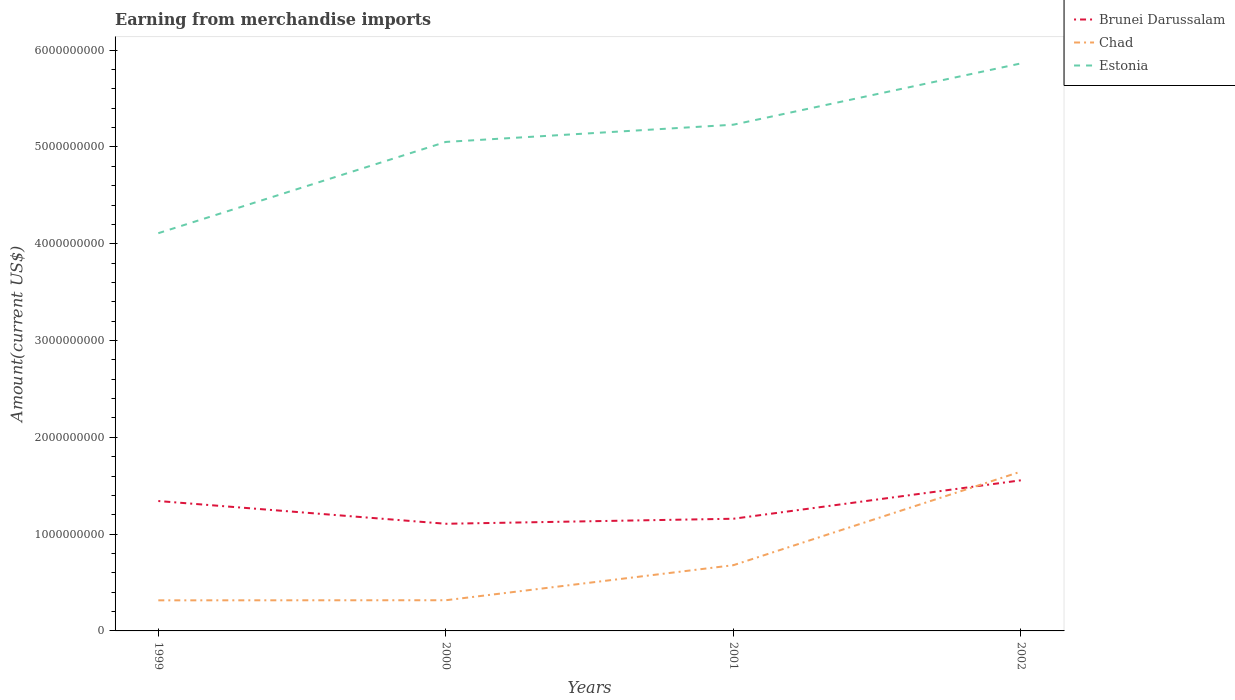How many different coloured lines are there?
Your response must be concise. 3. Is the number of lines equal to the number of legend labels?
Give a very brief answer. Yes. Across all years, what is the maximum amount earned from merchandise imports in Estonia?
Give a very brief answer. 4.11e+09. In which year was the amount earned from merchandise imports in Brunei Darussalam maximum?
Make the answer very short. 2000. What is the total amount earned from merchandise imports in Brunei Darussalam in the graph?
Give a very brief answer. -2.14e+08. What is the difference between the highest and the second highest amount earned from merchandise imports in Chad?
Provide a short and direct response. 1.33e+09. What is the difference between the highest and the lowest amount earned from merchandise imports in Chad?
Provide a succinct answer. 1. How many lines are there?
Offer a very short reply. 3. How many years are there in the graph?
Your answer should be compact. 4. Where does the legend appear in the graph?
Provide a succinct answer. Top right. How are the legend labels stacked?
Ensure brevity in your answer.  Vertical. What is the title of the graph?
Your answer should be compact. Earning from merchandise imports. Does "Andorra" appear as one of the legend labels in the graph?
Keep it short and to the point. No. What is the label or title of the X-axis?
Provide a succinct answer. Years. What is the label or title of the Y-axis?
Ensure brevity in your answer.  Amount(current US$). What is the Amount(current US$) in Brunei Darussalam in 1999?
Your response must be concise. 1.34e+09. What is the Amount(current US$) in Chad in 1999?
Offer a very short reply. 3.16e+08. What is the Amount(current US$) in Estonia in 1999?
Make the answer very short. 4.11e+09. What is the Amount(current US$) in Brunei Darussalam in 2000?
Provide a succinct answer. 1.11e+09. What is the Amount(current US$) of Chad in 2000?
Your response must be concise. 3.17e+08. What is the Amount(current US$) of Estonia in 2000?
Offer a very short reply. 5.05e+09. What is the Amount(current US$) of Brunei Darussalam in 2001?
Your answer should be compact. 1.16e+09. What is the Amount(current US$) of Chad in 2001?
Offer a terse response. 6.79e+08. What is the Amount(current US$) of Estonia in 2001?
Provide a succinct answer. 5.23e+09. What is the Amount(current US$) of Brunei Darussalam in 2002?
Your answer should be very brief. 1.56e+09. What is the Amount(current US$) of Chad in 2002?
Your answer should be very brief. 1.65e+09. What is the Amount(current US$) in Estonia in 2002?
Provide a short and direct response. 5.86e+09. Across all years, what is the maximum Amount(current US$) of Brunei Darussalam?
Keep it short and to the point. 1.56e+09. Across all years, what is the maximum Amount(current US$) in Chad?
Ensure brevity in your answer.  1.65e+09. Across all years, what is the maximum Amount(current US$) of Estonia?
Offer a terse response. 5.86e+09. Across all years, what is the minimum Amount(current US$) of Brunei Darussalam?
Make the answer very short. 1.11e+09. Across all years, what is the minimum Amount(current US$) of Chad?
Provide a short and direct response. 3.16e+08. Across all years, what is the minimum Amount(current US$) in Estonia?
Provide a short and direct response. 4.11e+09. What is the total Amount(current US$) of Brunei Darussalam in the graph?
Your answer should be compact. 5.16e+09. What is the total Amount(current US$) of Chad in the graph?
Your response must be concise. 2.96e+09. What is the total Amount(current US$) of Estonia in the graph?
Your answer should be very brief. 2.03e+1. What is the difference between the Amount(current US$) of Brunei Darussalam in 1999 and that in 2000?
Your response must be concise. 2.35e+08. What is the difference between the Amount(current US$) in Chad in 1999 and that in 2000?
Provide a succinct answer. -1.00e+06. What is the difference between the Amount(current US$) in Estonia in 1999 and that in 2000?
Your response must be concise. -9.43e+08. What is the difference between the Amount(current US$) of Brunei Darussalam in 1999 and that in 2001?
Keep it short and to the point. 1.83e+08. What is the difference between the Amount(current US$) of Chad in 1999 and that in 2001?
Make the answer very short. -3.63e+08. What is the difference between the Amount(current US$) in Estonia in 1999 and that in 2001?
Provide a short and direct response. -1.12e+09. What is the difference between the Amount(current US$) in Brunei Darussalam in 1999 and that in 2002?
Keep it short and to the point. -2.14e+08. What is the difference between the Amount(current US$) in Chad in 1999 and that in 2002?
Provide a short and direct response. -1.33e+09. What is the difference between the Amount(current US$) of Estonia in 1999 and that in 2002?
Give a very brief answer. -1.75e+09. What is the difference between the Amount(current US$) of Brunei Darussalam in 2000 and that in 2001?
Offer a terse response. -5.20e+07. What is the difference between the Amount(current US$) in Chad in 2000 and that in 2001?
Provide a succinct answer. -3.62e+08. What is the difference between the Amount(current US$) of Estonia in 2000 and that in 2001?
Provide a short and direct response. -1.78e+08. What is the difference between the Amount(current US$) in Brunei Darussalam in 2000 and that in 2002?
Offer a very short reply. -4.49e+08. What is the difference between the Amount(current US$) of Chad in 2000 and that in 2002?
Your response must be concise. -1.33e+09. What is the difference between the Amount(current US$) in Estonia in 2000 and that in 2002?
Give a very brief answer. -8.11e+08. What is the difference between the Amount(current US$) of Brunei Darussalam in 2001 and that in 2002?
Make the answer very short. -3.97e+08. What is the difference between the Amount(current US$) in Chad in 2001 and that in 2002?
Provide a succinct answer. -9.67e+08. What is the difference between the Amount(current US$) in Estonia in 2001 and that in 2002?
Ensure brevity in your answer.  -6.33e+08. What is the difference between the Amount(current US$) in Brunei Darussalam in 1999 and the Amount(current US$) in Chad in 2000?
Ensure brevity in your answer.  1.02e+09. What is the difference between the Amount(current US$) of Brunei Darussalam in 1999 and the Amount(current US$) of Estonia in 2000?
Offer a terse response. -3.71e+09. What is the difference between the Amount(current US$) in Chad in 1999 and the Amount(current US$) in Estonia in 2000?
Provide a short and direct response. -4.74e+09. What is the difference between the Amount(current US$) in Brunei Darussalam in 1999 and the Amount(current US$) in Chad in 2001?
Provide a succinct answer. 6.63e+08. What is the difference between the Amount(current US$) in Brunei Darussalam in 1999 and the Amount(current US$) in Estonia in 2001?
Offer a very short reply. -3.89e+09. What is the difference between the Amount(current US$) of Chad in 1999 and the Amount(current US$) of Estonia in 2001?
Give a very brief answer. -4.91e+09. What is the difference between the Amount(current US$) in Brunei Darussalam in 1999 and the Amount(current US$) in Chad in 2002?
Provide a succinct answer. -3.04e+08. What is the difference between the Amount(current US$) in Brunei Darussalam in 1999 and the Amount(current US$) in Estonia in 2002?
Offer a terse response. -4.52e+09. What is the difference between the Amount(current US$) in Chad in 1999 and the Amount(current US$) in Estonia in 2002?
Offer a terse response. -5.55e+09. What is the difference between the Amount(current US$) of Brunei Darussalam in 2000 and the Amount(current US$) of Chad in 2001?
Offer a very short reply. 4.28e+08. What is the difference between the Amount(current US$) of Brunei Darussalam in 2000 and the Amount(current US$) of Estonia in 2001?
Provide a short and direct response. -4.12e+09. What is the difference between the Amount(current US$) of Chad in 2000 and the Amount(current US$) of Estonia in 2001?
Provide a short and direct response. -4.91e+09. What is the difference between the Amount(current US$) of Brunei Darussalam in 2000 and the Amount(current US$) of Chad in 2002?
Ensure brevity in your answer.  -5.39e+08. What is the difference between the Amount(current US$) in Brunei Darussalam in 2000 and the Amount(current US$) in Estonia in 2002?
Keep it short and to the point. -4.76e+09. What is the difference between the Amount(current US$) in Chad in 2000 and the Amount(current US$) in Estonia in 2002?
Your response must be concise. -5.55e+09. What is the difference between the Amount(current US$) of Brunei Darussalam in 2001 and the Amount(current US$) of Chad in 2002?
Give a very brief answer. -4.87e+08. What is the difference between the Amount(current US$) of Brunei Darussalam in 2001 and the Amount(current US$) of Estonia in 2002?
Ensure brevity in your answer.  -4.70e+09. What is the difference between the Amount(current US$) of Chad in 2001 and the Amount(current US$) of Estonia in 2002?
Provide a short and direct response. -5.18e+09. What is the average Amount(current US$) in Brunei Darussalam per year?
Give a very brief answer. 1.29e+09. What is the average Amount(current US$) in Chad per year?
Make the answer very short. 7.40e+08. What is the average Amount(current US$) in Estonia per year?
Provide a succinct answer. 5.06e+09. In the year 1999, what is the difference between the Amount(current US$) of Brunei Darussalam and Amount(current US$) of Chad?
Offer a terse response. 1.03e+09. In the year 1999, what is the difference between the Amount(current US$) in Brunei Darussalam and Amount(current US$) in Estonia?
Offer a very short reply. -2.77e+09. In the year 1999, what is the difference between the Amount(current US$) in Chad and Amount(current US$) in Estonia?
Provide a succinct answer. -3.79e+09. In the year 2000, what is the difference between the Amount(current US$) in Brunei Darussalam and Amount(current US$) in Chad?
Your response must be concise. 7.90e+08. In the year 2000, what is the difference between the Amount(current US$) of Brunei Darussalam and Amount(current US$) of Estonia?
Keep it short and to the point. -3.94e+09. In the year 2000, what is the difference between the Amount(current US$) in Chad and Amount(current US$) in Estonia?
Provide a short and direct response. -4.74e+09. In the year 2001, what is the difference between the Amount(current US$) of Brunei Darussalam and Amount(current US$) of Chad?
Offer a terse response. 4.80e+08. In the year 2001, what is the difference between the Amount(current US$) of Brunei Darussalam and Amount(current US$) of Estonia?
Make the answer very short. -4.07e+09. In the year 2001, what is the difference between the Amount(current US$) of Chad and Amount(current US$) of Estonia?
Your answer should be compact. -4.55e+09. In the year 2002, what is the difference between the Amount(current US$) in Brunei Darussalam and Amount(current US$) in Chad?
Your answer should be compact. -9.00e+07. In the year 2002, what is the difference between the Amount(current US$) of Brunei Darussalam and Amount(current US$) of Estonia?
Ensure brevity in your answer.  -4.31e+09. In the year 2002, what is the difference between the Amount(current US$) in Chad and Amount(current US$) in Estonia?
Provide a short and direct response. -4.22e+09. What is the ratio of the Amount(current US$) in Brunei Darussalam in 1999 to that in 2000?
Offer a very short reply. 1.21. What is the ratio of the Amount(current US$) of Estonia in 1999 to that in 2000?
Make the answer very short. 0.81. What is the ratio of the Amount(current US$) of Brunei Darussalam in 1999 to that in 2001?
Give a very brief answer. 1.16. What is the ratio of the Amount(current US$) of Chad in 1999 to that in 2001?
Offer a very short reply. 0.47. What is the ratio of the Amount(current US$) in Estonia in 1999 to that in 2001?
Your answer should be compact. 0.79. What is the ratio of the Amount(current US$) in Brunei Darussalam in 1999 to that in 2002?
Offer a very short reply. 0.86. What is the ratio of the Amount(current US$) of Chad in 1999 to that in 2002?
Make the answer very short. 0.19. What is the ratio of the Amount(current US$) in Estonia in 1999 to that in 2002?
Provide a succinct answer. 0.7. What is the ratio of the Amount(current US$) of Brunei Darussalam in 2000 to that in 2001?
Provide a succinct answer. 0.96. What is the ratio of the Amount(current US$) in Chad in 2000 to that in 2001?
Offer a terse response. 0.47. What is the ratio of the Amount(current US$) of Estonia in 2000 to that in 2001?
Give a very brief answer. 0.97. What is the ratio of the Amount(current US$) of Brunei Darussalam in 2000 to that in 2002?
Offer a very short reply. 0.71. What is the ratio of the Amount(current US$) of Chad in 2000 to that in 2002?
Offer a terse response. 0.19. What is the ratio of the Amount(current US$) in Estonia in 2000 to that in 2002?
Ensure brevity in your answer.  0.86. What is the ratio of the Amount(current US$) of Brunei Darussalam in 2001 to that in 2002?
Provide a short and direct response. 0.74. What is the ratio of the Amount(current US$) of Chad in 2001 to that in 2002?
Your response must be concise. 0.41. What is the ratio of the Amount(current US$) in Estonia in 2001 to that in 2002?
Your response must be concise. 0.89. What is the difference between the highest and the second highest Amount(current US$) of Brunei Darussalam?
Offer a terse response. 2.14e+08. What is the difference between the highest and the second highest Amount(current US$) in Chad?
Provide a succinct answer. 9.67e+08. What is the difference between the highest and the second highest Amount(current US$) of Estonia?
Offer a terse response. 6.33e+08. What is the difference between the highest and the lowest Amount(current US$) of Brunei Darussalam?
Provide a succinct answer. 4.49e+08. What is the difference between the highest and the lowest Amount(current US$) of Chad?
Make the answer very short. 1.33e+09. What is the difference between the highest and the lowest Amount(current US$) of Estonia?
Offer a terse response. 1.75e+09. 